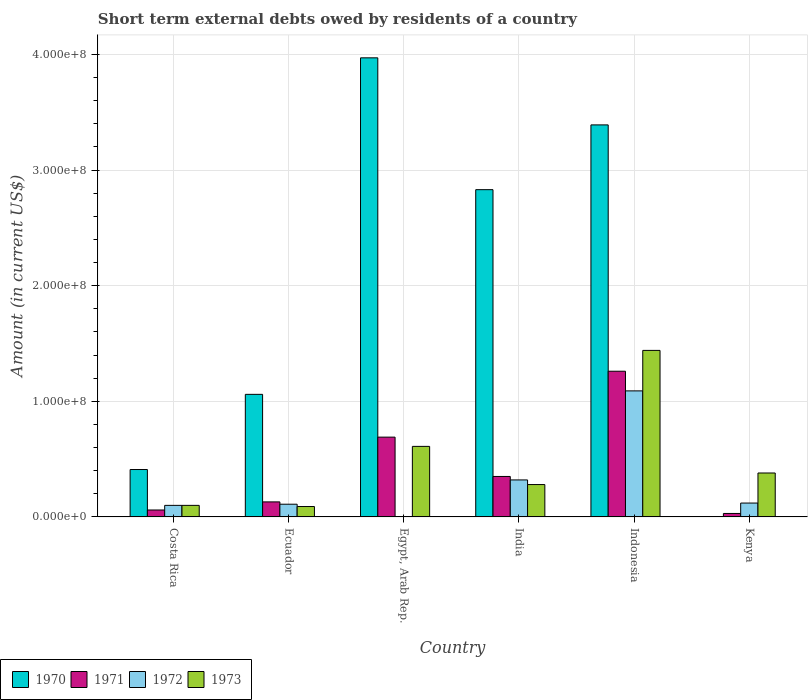How many different coloured bars are there?
Make the answer very short. 4. How many groups of bars are there?
Offer a terse response. 6. Are the number of bars per tick equal to the number of legend labels?
Offer a very short reply. No. Are the number of bars on each tick of the X-axis equal?
Your answer should be very brief. No. How many bars are there on the 6th tick from the left?
Keep it short and to the point. 3. In how many cases, is the number of bars for a given country not equal to the number of legend labels?
Make the answer very short. 2. What is the amount of short-term external debts owed by residents in 1970 in Indonesia?
Provide a short and direct response. 3.39e+08. Across all countries, what is the maximum amount of short-term external debts owed by residents in 1973?
Keep it short and to the point. 1.44e+08. Across all countries, what is the minimum amount of short-term external debts owed by residents in 1973?
Give a very brief answer. 9.00e+06. In which country was the amount of short-term external debts owed by residents in 1970 maximum?
Give a very brief answer. Egypt, Arab Rep. What is the total amount of short-term external debts owed by residents in 1970 in the graph?
Give a very brief answer. 1.17e+09. What is the difference between the amount of short-term external debts owed by residents in 1971 in Ecuador and that in Kenya?
Make the answer very short. 1.00e+07. What is the difference between the amount of short-term external debts owed by residents in 1970 in Kenya and the amount of short-term external debts owed by residents in 1972 in Indonesia?
Offer a very short reply. -1.09e+08. What is the average amount of short-term external debts owed by residents in 1972 per country?
Provide a short and direct response. 2.90e+07. What is the difference between the amount of short-term external debts owed by residents of/in 1973 and amount of short-term external debts owed by residents of/in 1972 in Indonesia?
Keep it short and to the point. 3.50e+07. What is the ratio of the amount of short-term external debts owed by residents in 1970 in Ecuador to that in Indonesia?
Give a very brief answer. 0.31. What is the difference between the highest and the second highest amount of short-term external debts owed by residents in 1971?
Provide a succinct answer. 5.70e+07. What is the difference between the highest and the lowest amount of short-term external debts owed by residents in 1971?
Provide a short and direct response. 1.23e+08. In how many countries, is the amount of short-term external debts owed by residents in 1972 greater than the average amount of short-term external debts owed by residents in 1972 taken over all countries?
Provide a short and direct response. 2. Is the sum of the amount of short-term external debts owed by residents in 1971 in Ecuador and India greater than the maximum amount of short-term external debts owed by residents in 1972 across all countries?
Offer a terse response. No. Are all the bars in the graph horizontal?
Make the answer very short. No. How many countries are there in the graph?
Provide a short and direct response. 6. Does the graph contain any zero values?
Provide a short and direct response. Yes. Where does the legend appear in the graph?
Offer a very short reply. Bottom left. How many legend labels are there?
Offer a terse response. 4. What is the title of the graph?
Provide a short and direct response. Short term external debts owed by residents of a country. What is the label or title of the X-axis?
Make the answer very short. Country. What is the label or title of the Y-axis?
Give a very brief answer. Amount (in current US$). What is the Amount (in current US$) in 1970 in Costa Rica?
Provide a succinct answer. 4.10e+07. What is the Amount (in current US$) in 1972 in Costa Rica?
Provide a succinct answer. 1.00e+07. What is the Amount (in current US$) in 1973 in Costa Rica?
Your answer should be very brief. 1.00e+07. What is the Amount (in current US$) of 1970 in Ecuador?
Keep it short and to the point. 1.06e+08. What is the Amount (in current US$) in 1971 in Ecuador?
Make the answer very short. 1.30e+07. What is the Amount (in current US$) in 1972 in Ecuador?
Your answer should be compact. 1.10e+07. What is the Amount (in current US$) of 1973 in Ecuador?
Your answer should be very brief. 9.00e+06. What is the Amount (in current US$) in 1970 in Egypt, Arab Rep.?
Ensure brevity in your answer.  3.97e+08. What is the Amount (in current US$) in 1971 in Egypt, Arab Rep.?
Your response must be concise. 6.90e+07. What is the Amount (in current US$) of 1972 in Egypt, Arab Rep.?
Offer a very short reply. 0. What is the Amount (in current US$) of 1973 in Egypt, Arab Rep.?
Your response must be concise. 6.10e+07. What is the Amount (in current US$) in 1970 in India?
Provide a succinct answer. 2.83e+08. What is the Amount (in current US$) in 1971 in India?
Provide a succinct answer. 3.50e+07. What is the Amount (in current US$) in 1972 in India?
Your answer should be compact. 3.20e+07. What is the Amount (in current US$) in 1973 in India?
Your response must be concise. 2.80e+07. What is the Amount (in current US$) of 1970 in Indonesia?
Ensure brevity in your answer.  3.39e+08. What is the Amount (in current US$) of 1971 in Indonesia?
Make the answer very short. 1.26e+08. What is the Amount (in current US$) of 1972 in Indonesia?
Offer a very short reply. 1.09e+08. What is the Amount (in current US$) of 1973 in Indonesia?
Provide a short and direct response. 1.44e+08. What is the Amount (in current US$) in 1971 in Kenya?
Ensure brevity in your answer.  3.00e+06. What is the Amount (in current US$) in 1973 in Kenya?
Provide a succinct answer. 3.80e+07. Across all countries, what is the maximum Amount (in current US$) in 1970?
Offer a terse response. 3.97e+08. Across all countries, what is the maximum Amount (in current US$) of 1971?
Keep it short and to the point. 1.26e+08. Across all countries, what is the maximum Amount (in current US$) in 1972?
Your answer should be very brief. 1.09e+08. Across all countries, what is the maximum Amount (in current US$) in 1973?
Offer a very short reply. 1.44e+08. Across all countries, what is the minimum Amount (in current US$) of 1972?
Provide a succinct answer. 0. Across all countries, what is the minimum Amount (in current US$) in 1973?
Provide a short and direct response. 9.00e+06. What is the total Amount (in current US$) of 1970 in the graph?
Your response must be concise. 1.17e+09. What is the total Amount (in current US$) in 1971 in the graph?
Provide a short and direct response. 2.52e+08. What is the total Amount (in current US$) in 1972 in the graph?
Provide a short and direct response. 1.74e+08. What is the total Amount (in current US$) in 1973 in the graph?
Your answer should be very brief. 2.90e+08. What is the difference between the Amount (in current US$) in 1970 in Costa Rica and that in Ecuador?
Offer a very short reply. -6.50e+07. What is the difference between the Amount (in current US$) of 1971 in Costa Rica and that in Ecuador?
Keep it short and to the point. -7.00e+06. What is the difference between the Amount (in current US$) in 1973 in Costa Rica and that in Ecuador?
Provide a short and direct response. 1.00e+06. What is the difference between the Amount (in current US$) of 1970 in Costa Rica and that in Egypt, Arab Rep.?
Keep it short and to the point. -3.56e+08. What is the difference between the Amount (in current US$) in 1971 in Costa Rica and that in Egypt, Arab Rep.?
Ensure brevity in your answer.  -6.30e+07. What is the difference between the Amount (in current US$) in 1973 in Costa Rica and that in Egypt, Arab Rep.?
Your response must be concise. -5.10e+07. What is the difference between the Amount (in current US$) of 1970 in Costa Rica and that in India?
Provide a succinct answer. -2.42e+08. What is the difference between the Amount (in current US$) in 1971 in Costa Rica and that in India?
Offer a very short reply. -2.90e+07. What is the difference between the Amount (in current US$) of 1972 in Costa Rica and that in India?
Offer a very short reply. -2.20e+07. What is the difference between the Amount (in current US$) of 1973 in Costa Rica and that in India?
Ensure brevity in your answer.  -1.80e+07. What is the difference between the Amount (in current US$) in 1970 in Costa Rica and that in Indonesia?
Provide a short and direct response. -2.98e+08. What is the difference between the Amount (in current US$) of 1971 in Costa Rica and that in Indonesia?
Your answer should be very brief. -1.20e+08. What is the difference between the Amount (in current US$) in 1972 in Costa Rica and that in Indonesia?
Make the answer very short. -9.90e+07. What is the difference between the Amount (in current US$) in 1973 in Costa Rica and that in Indonesia?
Provide a succinct answer. -1.34e+08. What is the difference between the Amount (in current US$) of 1971 in Costa Rica and that in Kenya?
Give a very brief answer. 3.00e+06. What is the difference between the Amount (in current US$) of 1972 in Costa Rica and that in Kenya?
Offer a terse response. -2.00e+06. What is the difference between the Amount (in current US$) in 1973 in Costa Rica and that in Kenya?
Offer a terse response. -2.80e+07. What is the difference between the Amount (in current US$) of 1970 in Ecuador and that in Egypt, Arab Rep.?
Make the answer very short. -2.91e+08. What is the difference between the Amount (in current US$) of 1971 in Ecuador and that in Egypt, Arab Rep.?
Offer a terse response. -5.60e+07. What is the difference between the Amount (in current US$) of 1973 in Ecuador and that in Egypt, Arab Rep.?
Give a very brief answer. -5.20e+07. What is the difference between the Amount (in current US$) of 1970 in Ecuador and that in India?
Give a very brief answer. -1.77e+08. What is the difference between the Amount (in current US$) of 1971 in Ecuador and that in India?
Offer a very short reply. -2.20e+07. What is the difference between the Amount (in current US$) of 1972 in Ecuador and that in India?
Offer a terse response. -2.10e+07. What is the difference between the Amount (in current US$) of 1973 in Ecuador and that in India?
Your answer should be very brief. -1.90e+07. What is the difference between the Amount (in current US$) in 1970 in Ecuador and that in Indonesia?
Your answer should be compact. -2.33e+08. What is the difference between the Amount (in current US$) of 1971 in Ecuador and that in Indonesia?
Provide a short and direct response. -1.13e+08. What is the difference between the Amount (in current US$) of 1972 in Ecuador and that in Indonesia?
Your answer should be compact. -9.80e+07. What is the difference between the Amount (in current US$) of 1973 in Ecuador and that in Indonesia?
Ensure brevity in your answer.  -1.35e+08. What is the difference between the Amount (in current US$) in 1971 in Ecuador and that in Kenya?
Provide a short and direct response. 1.00e+07. What is the difference between the Amount (in current US$) in 1973 in Ecuador and that in Kenya?
Make the answer very short. -2.90e+07. What is the difference between the Amount (in current US$) in 1970 in Egypt, Arab Rep. and that in India?
Ensure brevity in your answer.  1.14e+08. What is the difference between the Amount (in current US$) in 1971 in Egypt, Arab Rep. and that in India?
Your response must be concise. 3.40e+07. What is the difference between the Amount (in current US$) in 1973 in Egypt, Arab Rep. and that in India?
Ensure brevity in your answer.  3.30e+07. What is the difference between the Amount (in current US$) of 1970 in Egypt, Arab Rep. and that in Indonesia?
Offer a terse response. 5.80e+07. What is the difference between the Amount (in current US$) of 1971 in Egypt, Arab Rep. and that in Indonesia?
Give a very brief answer. -5.70e+07. What is the difference between the Amount (in current US$) in 1973 in Egypt, Arab Rep. and that in Indonesia?
Ensure brevity in your answer.  -8.30e+07. What is the difference between the Amount (in current US$) in 1971 in Egypt, Arab Rep. and that in Kenya?
Provide a short and direct response. 6.60e+07. What is the difference between the Amount (in current US$) in 1973 in Egypt, Arab Rep. and that in Kenya?
Your response must be concise. 2.30e+07. What is the difference between the Amount (in current US$) of 1970 in India and that in Indonesia?
Provide a succinct answer. -5.60e+07. What is the difference between the Amount (in current US$) in 1971 in India and that in Indonesia?
Make the answer very short. -9.10e+07. What is the difference between the Amount (in current US$) of 1972 in India and that in Indonesia?
Offer a terse response. -7.70e+07. What is the difference between the Amount (in current US$) of 1973 in India and that in Indonesia?
Keep it short and to the point. -1.16e+08. What is the difference between the Amount (in current US$) in 1971 in India and that in Kenya?
Keep it short and to the point. 3.20e+07. What is the difference between the Amount (in current US$) in 1972 in India and that in Kenya?
Offer a terse response. 2.00e+07. What is the difference between the Amount (in current US$) in 1973 in India and that in Kenya?
Provide a succinct answer. -1.00e+07. What is the difference between the Amount (in current US$) of 1971 in Indonesia and that in Kenya?
Your response must be concise. 1.23e+08. What is the difference between the Amount (in current US$) of 1972 in Indonesia and that in Kenya?
Provide a succinct answer. 9.70e+07. What is the difference between the Amount (in current US$) of 1973 in Indonesia and that in Kenya?
Offer a very short reply. 1.06e+08. What is the difference between the Amount (in current US$) of 1970 in Costa Rica and the Amount (in current US$) of 1971 in Ecuador?
Give a very brief answer. 2.80e+07. What is the difference between the Amount (in current US$) of 1970 in Costa Rica and the Amount (in current US$) of 1972 in Ecuador?
Offer a very short reply. 3.00e+07. What is the difference between the Amount (in current US$) of 1970 in Costa Rica and the Amount (in current US$) of 1973 in Ecuador?
Your answer should be compact. 3.20e+07. What is the difference between the Amount (in current US$) in 1971 in Costa Rica and the Amount (in current US$) in 1972 in Ecuador?
Provide a succinct answer. -5.00e+06. What is the difference between the Amount (in current US$) in 1970 in Costa Rica and the Amount (in current US$) in 1971 in Egypt, Arab Rep.?
Your answer should be very brief. -2.80e+07. What is the difference between the Amount (in current US$) of 1970 in Costa Rica and the Amount (in current US$) of 1973 in Egypt, Arab Rep.?
Provide a succinct answer. -2.00e+07. What is the difference between the Amount (in current US$) of 1971 in Costa Rica and the Amount (in current US$) of 1973 in Egypt, Arab Rep.?
Provide a short and direct response. -5.50e+07. What is the difference between the Amount (in current US$) in 1972 in Costa Rica and the Amount (in current US$) in 1973 in Egypt, Arab Rep.?
Provide a short and direct response. -5.10e+07. What is the difference between the Amount (in current US$) in 1970 in Costa Rica and the Amount (in current US$) in 1971 in India?
Keep it short and to the point. 6.00e+06. What is the difference between the Amount (in current US$) of 1970 in Costa Rica and the Amount (in current US$) of 1972 in India?
Give a very brief answer. 9.00e+06. What is the difference between the Amount (in current US$) in 1970 in Costa Rica and the Amount (in current US$) in 1973 in India?
Provide a succinct answer. 1.30e+07. What is the difference between the Amount (in current US$) of 1971 in Costa Rica and the Amount (in current US$) of 1972 in India?
Your answer should be very brief. -2.60e+07. What is the difference between the Amount (in current US$) in 1971 in Costa Rica and the Amount (in current US$) in 1973 in India?
Make the answer very short. -2.20e+07. What is the difference between the Amount (in current US$) of 1972 in Costa Rica and the Amount (in current US$) of 1973 in India?
Offer a terse response. -1.80e+07. What is the difference between the Amount (in current US$) of 1970 in Costa Rica and the Amount (in current US$) of 1971 in Indonesia?
Keep it short and to the point. -8.50e+07. What is the difference between the Amount (in current US$) in 1970 in Costa Rica and the Amount (in current US$) in 1972 in Indonesia?
Keep it short and to the point. -6.80e+07. What is the difference between the Amount (in current US$) of 1970 in Costa Rica and the Amount (in current US$) of 1973 in Indonesia?
Your answer should be compact. -1.03e+08. What is the difference between the Amount (in current US$) of 1971 in Costa Rica and the Amount (in current US$) of 1972 in Indonesia?
Your answer should be compact. -1.03e+08. What is the difference between the Amount (in current US$) in 1971 in Costa Rica and the Amount (in current US$) in 1973 in Indonesia?
Give a very brief answer. -1.38e+08. What is the difference between the Amount (in current US$) of 1972 in Costa Rica and the Amount (in current US$) of 1973 in Indonesia?
Ensure brevity in your answer.  -1.34e+08. What is the difference between the Amount (in current US$) of 1970 in Costa Rica and the Amount (in current US$) of 1971 in Kenya?
Ensure brevity in your answer.  3.80e+07. What is the difference between the Amount (in current US$) of 1970 in Costa Rica and the Amount (in current US$) of 1972 in Kenya?
Make the answer very short. 2.90e+07. What is the difference between the Amount (in current US$) of 1970 in Costa Rica and the Amount (in current US$) of 1973 in Kenya?
Provide a short and direct response. 3.00e+06. What is the difference between the Amount (in current US$) of 1971 in Costa Rica and the Amount (in current US$) of 1972 in Kenya?
Give a very brief answer. -6.00e+06. What is the difference between the Amount (in current US$) in 1971 in Costa Rica and the Amount (in current US$) in 1973 in Kenya?
Offer a terse response. -3.20e+07. What is the difference between the Amount (in current US$) of 1972 in Costa Rica and the Amount (in current US$) of 1973 in Kenya?
Offer a very short reply. -2.80e+07. What is the difference between the Amount (in current US$) of 1970 in Ecuador and the Amount (in current US$) of 1971 in Egypt, Arab Rep.?
Ensure brevity in your answer.  3.70e+07. What is the difference between the Amount (in current US$) of 1970 in Ecuador and the Amount (in current US$) of 1973 in Egypt, Arab Rep.?
Give a very brief answer. 4.50e+07. What is the difference between the Amount (in current US$) in 1971 in Ecuador and the Amount (in current US$) in 1973 in Egypt, Arab Rep.?
Your response must be concise. -4.80e+07. What is the difference between the Amount (in current US$) in 1972 in Ecuador and the Amount (in current US$) in 1973 in Egypt, Arab Rep.?
Ensure brevity in your answer.  -5.00e+07. What is the difference between the Amount (in current US$) in 1970 in Ecuador and the Amount (in current US$) in 1971 in India?
Keep it short and to the point. 7.10e+07. What is the difference between the Amount (in current US$) in 1970 in Ecuador and the Amount (in current US$) in 1972 in India?
Your response must be concise. 7.40e+07. What is the difference between the Amount (in current US$) of 1970 in Ecuador and the Amount (in current US$) of 1973 in India?
Offer a terse response. 7.80e+07. What is the difference between the Amount (in current US$) of 1971 in Ecuador and the Amount (in current US$) of 1972 in India?
Offer a very short reply. -1.90e+07. What is the difference between the Amount (in current US$) of 1971 in Ecuador and the Amount (in current US$) of 1973 in India?
Ensure brevity in your answer.  -1.50e+07. What is the difference between the Amount (in current US$) in 1972 in Ecuador and the Amount (in current US$) in 1973 in India?
Give a very brief answer. -1.70e+07. What is the difference between the Amount (in current US$) of 1970 in Ecuador and the Amount (in current US$) of 1971 in Indonesia?
Ensure brevity in your answer.  -2.00e+07. What is the difference between the Amount (in current US$) of 1970 in Ecuador and the Amount (in current US$) of 1973 in Indonesia?
Provide a succinct answer. -3.80e+07. What is the difference between the Amount (in current US$) of 1971 in Ecuador and the Amount (in current US$) of 1972 in Indonesia?
Your response must be concise. -9.60e+07. What is the difference between the Amount (in current US$) of 1971 in Ecuador and the Amount (in current US$) of 1973 in Indonesia?
Offer a very short reply. -1.31e+08. What is the difference between the Amount (in current US$) of 1972 in Ecuador and the Amount (in current US$) of 1973 in Indonesia?
Give a very brief answer. -1.33e+08. What is the difference between the Amount (in current US$) of 1970 in Ecuador and the Amount (in current US$) of 1971 in Kenya?
Make the answer very short. 1.03e+08. What is the difference between the Amount (in current US$) of 1970 in Ecuador and the Amount (in current US$) of 1972 in Kenya?
Your answer should be compact. 9.40e+07. What is the difference between the Amount (in current US$) in 1970 in Ecuador and the Amount (in current US$) in 1973 in Kenya?
Give a very brief answer. 6.80e+07. What is the difference between the Amount (in current US$) of 1971 in Ecuador and the Amount (in current US$) of 1972 in Kenya?
Provide a succinct answer. 1.00e+06. What is the difference between the Amount (in current US$) of 1971 in Ecuador and the Amount (in current US$) of 1973 in Kenya?
Ensure brevity in your answer.  -2.50e+07. What is the difference between the Amount (in current US$) in 1972 in Ecuador and the Amount (in current US$) in 1973 in Kenya?
Your response must be concise. -2.70e+07. What is the difference between the Amount (in current US$) in 1970 in Egypt, Arab Rep. and the Amount (in current US$) in 1971 in India?
Offer a very short reply. 3.62e+08. What is the difference between the Amount (in current US$) in 1970 in Egypt, Arab Rep. and the Amount (in current US$) in 1972 in India?
Ensure brevity in your answer.  3.65e+08. What is the difference between the Amount (in current US$) in 1970 in Egypt, Arab Rep. and the Amount (in current US$) in 1973 in India?
Give a very brief answer. 3.69e+08. What is the difference between the Amount (in current US$) in 1971 in Egypt, Arab Rep. and the Amount (in current US$) in 1972 in India?
Make the answer very short. 3.70e+07. What is the difference between the Amount (in current US$) in 1971 in Egypt, Arab Rep. and the Amount (in current US$) in 1973 in India?
Offer a very short reply. 4.10e+07. What is the difference between the Amount (in current US$) of 1970 in Egypt, Arab Rep. and the Amount (in current US$) of 1971 in Indonesia?
Offer a terse response. 2.71e+08. What is the difference between the Amount (in current US$) in 1970 in Egypt, Arab Rep. and the Amount (in current US$) in 1972 in Indonesia?
Provide a succinct answer. 2.88e+08. What is the difference between the Amount (in current US$) in 1970 in Egypt, Arab Rep. and the Amount (in current US$) in 1973 in Indonesia?
Your response must be concise. 2.53e+08. What is the difference between the Amount (in current US$) in 1971 in Egypt, Arab Rep. and the Amount (in current US$) in 1972 in Indonesia?
Your answer should be compact. -4.00e+07. What is the difference between the Amount (in current US$) of 1971 in Egypt, Arab Rep. and the Amount (in current US$) of 1973 in Indonesia?
Ensure brevity in your answer.  -7.50e+07. What is the difference between the Amount (in current US$) in 1970 in Egypt, Arab Rep. and the Amount (in current US$) in 1971 in Kenya?
Provide a succinct answer. 3.94e+08. What is the difference between the Amount (in current US$) of 1970 in Egypt, Arab Rep. and the Amount (in current US$) of 1972 in Kenya?
Provide a short and direct response. 3.85e+08. What is the difference between the Amount (in current US$) of 1970 in Egypt, Arab Rep. and the Amount (in current US$) of 1973 in Kenya?
Keep it short and to the point. 3.59e+08. What is the difference between the Amount (in current US$) of 1971 in Egypt, Arab Rep. and the Amount (in current US$) of 1972 in Kenya?
Keep it short and to the point. 5.70e+07. What is the difference between the Amount (in current US$) of 1971 in Egypt, Arab Rep. and the Amount (in current US$) of 1973 in Kenya?
Offer a terse response. 3.10e+07. What is the difference between the Amount (in current US$) in 1970 in India and the Amount (in current US$) in 1971 in Indonesia?
Your answer should be very brief. 1.57e+08. What is the difference between the Amount (in current US$) of 1970 in India and the Amount (in current US$) of 1972 in Indonesia?
Your answer should be compact. 1.74e+08. What is the difference between the Amount (in current US$) of 1970 in India and the Amount (in current US$) of 1973 in Indonesia?
Your answer should be very brief. 1.39e+08. What is the difference between the Amount (in current US$) in 1971 in India and the Amount (in current US$) in 1972 in Indonesia?
Your response must be concise. -7.40e+07. What is the difference between the Amount (in current US$) in 1971 in India and the Amount (in current US$) in 1973 in Indonesia?
Your answer should be very brief. -1.09e+08. What is the difference between the Amount (in current US$) of 1972 in India and the Amount (in current US$) of 1973 in Indonesia?
Keep it short and to the point. -1.12e+08. What is the difference between the Amount (in current US$) in 1970 in India and the Amount (in current US$) in 1971 in Kenya?
Give a very brief answer. 2.80e+08. What is the difference between the Amount (in current US$) in 1970 in India and the Amount (in current US$) in 1972 in Kenya?
Give a very brief answer. 2.71e+08. What is the difference between the Amount (in current US$) of 1970 in India and the Amount (in current US$) of 1973 in Kenya?
Give a very brief answer. 2.45e+08. What is the difference between the Amount (in current US$) of 1971 in India and the Amount (in current US$) of 1972 in Kenya?
Your answer should be compact. 2.30e+07. What is the difference between the Amount (in current US$) of 1971 in India and the Amount (in current US$) of 1973 in Kenya?
Your answer should be compact. -3.00e+06. What is the difference between the Amount (in current US$) in 1972 in India and the Amount (in current US$) in 1973 in Kenya?
Give a very brief answer. -6.00e+06. What is the difference between the Amount (in current US$) of 1970 in Indonesia and the Amount (in current US$) of 1971 in Kenya?
Provide a short and direct response. 3.36e+08. What is the difference between the Amount (in current US$) of 1970 in Indonesia and the Amount (in current US$) of 1972 in Kenya?
Your answer should be compact. 3.27e+08. What is the difference between the Amount (in current US$) of 1970 in Indonesia and the Amount (in current US$) of 1973 in Kenya?
Ensure brevity in your answer.  3.01e+08. What is the difference between the Amount (in current US$) in 1971 in Indonesia and the Amount (in current US$) in 1972 in Kenya?
Keep it short and to the point. 1.14e+08. What is the difference between the Amount (in current US$) of 1971 in Indonesia and the Amount (in current US$) of 1973 in Kenya?
Make the answer very short. 8.80e+07. What is the difference between the Amount (in current US$) in 1972 in Indonesia and the Amount (in current US$) in 1973 in Kenya?
Your response must be concise. 7.10e+07. What is the average Amount (in current US$) of 1970 per country?
Offer a terse response. 1.94e+08. What is the average Amount (in current US$) of 1971 per country?
Provide a short and direct response. 4.20e+07. What is the average Amount (in current US$) in 1972 per country?
Your answer should be very brief. 2.90e+07. What is the average Amount (in current US$) in 1973 per country?
Keep it short and to the point. 4.83e+07. What is the difference between the Amount (in current US$) in 1970 and Amount (in current US$) in 1971 in Costa Rica?
Your answer should be compact. 3.50e+07. What is the difference between the Amount (in current US$) in 1970 and Amount (in current US$) in 1972 in Costa Rica?
Make the answer very short. 3.10e+07. What is the difference between the Amount (in current US$) of 1970 and Amount (in current US$) of 1973 in Costa Rica?
Make the answer very short. 3.10e+07. What is the difference between the Amount (in current US$) in 1970 and Amount (in current US$) in 1971 in Ecuador?
Ensure brevity in your answer.  9.30e+07. What is the difference between the Amount (in current US$) in 1970 and Amount (in current US$) in 1972 in Ecuador?
Provide a short and direct response. 9.50e+07. What is the difference between the Amount (in current US$) of 1970 and Amount (in current US$) of 1973 in Ecuador?
Make the answer very short. 9.70e+07. What is the difference between the Amount (in current US$) in 1971 and Amount (in current US$) in 1973 in Ecuador?
Provide a short and direct response. 4.00e+06. What is the difference between the Amount (in current US$) of 1970 and Amount (in current US$) of 1971 in Egypt, Arab Rep.?
Provide a short and direct response. 3.28e+08. What is the difference between the Amount (in current US$) in 1970 and Amount (in current US$) in 1973 in Egypt, Arab Rep.?
Ensure brevity in your answer.  3.36e+08. What is the difference between the Amount (in current US$) of 1971 and Amount (in current US$) of 1973 in Egypt, Arab Rep.?
Your response must be concise. 8.00e+06. What is the difference between the Amount (in current US$) of 1970 and Amount (in current US$) of 1971 in India?
Your response must be concise. 2.48e+08. What is the difference between the Amount (in current US$) in 1970 and Amount (in current US$) in 1972 in India?
Keep it short and to the point. 2.51e+08. What is the difference between the Amount (in current US$) in 1970 and Amount (in current US$) in 1973 in India?
Your response must be concise. 2.55e+08. What is the difference between the Amount (in current US$) in 1972 and Amount (in current US$) in 1973 in India?
Your response must be concise. 4.00e+06. What is the difference between the Amount (in current US$) of 1970 and Amount (in current US$) of 1971 in Indonesia?
Ensure brevity in your answer.  2.13e+08. What is the difference between the Amount (in current US$) in 1970 and Amount (in current US$) in 1972 in Indonesia?
Provide a short and direct response. 2.30e+08. What is the difference between the Amount (in current US$) in 1970 and Amount (in current US$) in 1973 in Indonesia?
Provide a short and direct response. 1.95e+08. What is the difference between the Amount (in current US$) in 1971 and Amount (in current US$) in 1972 in Indonesia?
Your answer should be compact. 1.70e+07. What is the difference between the Amount (in current US$) of 1971 and Amount (in current US$) of 1973 in Indonesia?
Your answer should be very brief. -1.80e+07. What is the difference between the Amount (in current US$) in 1972 and Amount (in current US$) in 1973 in Indonesia?
Provide a short and direct response. -3.50e+07. What is the difference between the Amount (in current US$) in 1971 and Amount (in current US$) in 1972 in Kenya?
Make the answer very short. -9.00e+06. What is the difference between the Amount (in current US$) of 1971 and Amount (in current US$) of 1973 in Kenya?
Ensure brevity in your answer.  -3.50e+07. What is the difference between the Amount (in current US$) of 1972 and Amount (in current US$) of 1973 in Kenya?
Provide a short and direct response. -2.60e+07. What is the ratio of the Amount (in current US$) in 1970 in Costa Rica to that in Ecuador?
Give a very brief answer. 0.39. What is the ratio of the Amount (in current US$) of 1971 in Costa Rica to that in Ecuador?
Provide a short and direct response. 0.46. What is the ratio of the Amount (in current US$) of 1972 in Costa Rica to that in Ecuador?
Your response must be concise. 0.91. What is the ratio of the Amount (in current US$) of 1970 in Costa Rica to that in Egypt, Arab Rep.?
Keep it short and to the point. 0.1. What is the ratio of the Amount (in current US$) of 1971 in Costa Rica to that in Egypt, Arab Rep.?
Your response must be concise. 0.09. What is the ratio of the Amount (in current US$) in 1973 in Costa Rica to that in Egypt, Arab Rep.?
Keep it short and to the point. 0.16. What is the ratio of the Amount (in current US$) in 1970 in Costa Rica to that in India?
Keep it short and to the point. 0.14. What is the ratio of the Amount (in current US$) in 1971 in Costa Rica to that in India?
Your answer should be very brief. 0.17. What is the ratio of the Amount (in current US$) of 1972 in Costa Rica to that in India?
Your response must be concise. 0.31. What is the ratio of the Amount (in current US$) in 1973 in Costa Rica to that in India?
Provide a succinct answer. 0.36. What is the ratio of the Amount (in current US$) in 1970 in Costa Rica to that in Indonesia?
Ensure brevity in your answer.  0.12. What is the ratio of the Amount (in current US$) of 1971 in Costa Rica to that in Indonesia?
Your answer should be compact. 0.05. What is the ratio of the Amount (in current US$) in 1972 in Costa Rica to that in Indonesia?
Your answer should be very brief. 0.09. What is the ratio of the Amount (in current US$) in 1973 in Costa Rica to that in Indonesia?
Your response must be concise. 0.07. What is the ratio of the Amount (in current US$) in 1973 in Costa Rica to that in Kenya?
Offer a terse response. 0.26. What is the ratio of the Amount (in current US$) of 1970 in Ecuador to that in Egypt, Arab Rep.?
Offer a very short reply. 0.27. What is the ratio of the Amount (in current US$) of 1971 in Ecuador to that in Egypt, Arab Rep.?
Offer a very short reply. 0.19. What is the ratio of the Amount (in current US$) of 1973 in Ecuador to that in Egypt, Arab Rep.?
Provide a succinct answer. 0.15. What is the ratio of the Amount (in current US$) in 1970 in Ecuador to that in India?
Offer a terse response. 0.37. What is the ratio of the Amount (in current US$) of 1971 in Ecuador to that in India?
Keep it short and to the point. 0.37. What is the ratio of the Amount (in current US$) in 1972 in Ecuador to that in India?
Offer a terse response. 0.34. What is the ratio of the Amount (in current US$) in 1973 in Ecuador to that in India?
Your response must be concise. 0.32. What is the ratio of the Amount (in current US$) in 1970 in Ecuador to that in Indonesia?
Give a very brief answer. 0.31. What is the ratio of the Amount (in current US$) of 1971 in Ecuador to that in Indonesia?
Provide a succinct answer. 0.1. What is the ratio of the Amount (in current US$) of 1972 in Ecuador to that in Indonesia?
Offer a terse response. 0.1. What is the ratio of the Amount (in current US$) in 1973 in Ecuador to that in Indonesia?
Provide a succinct answer. 0.06. What is the ratio of the Amount (in current US$) in 1971 in Ecuador to that in Kenya?
Give a very brief answer. 4.33. What is the ratio of the Amount (in current US$) in 1972 in Ecuador to that in Kenya?
Your answer should be compact. 0.92. What is the ratio of the Amount (in current US$) of 1973 in Ecuador to that in Kenya?
Keep it short and to the point. 0.24. What is the ratio of the Amount (in current US$) in 1970 in Egypt, Arab Rep. to that in India?
Offer a terse response. 1.4. What is the ratio of the Amount (in current US$) in 1971 in Egypt, Arab Rep. to that in India?
Ensure brevity in your answer.  1.97. What is the ratio of the Amount (in current US$) in 1973 in Egypt, Arab Rep. to that in India?
Your answer should be compact. 2.18. What is the ratio of the Amount (in current US$) in 1970 in Egypt, Arab Rep. to that in Indonesia?
Your answer should be compact. 1.17. What is the ratio of the Amount (in current US$) of 1971 in Egypt, Arab Rep. to that in Indonesia?
Provide a short and direct response. 0.55. What is the ratio of the Amount (in current US$) in 1973 in Egypt, Arab Rep. to that in Indonesia?
Your answer should be very brief. 0.42. What is the ratio of the Amount (in current US$) in 1973 in Egypt, Arab Rep. to that in Kenya?
Provide a short and direct response. 1.61. What is the ratio of the Amount (in current US$) in 1970 in India to that in Indonesia?
Provide a short and direct response. 0.83. What is the ratio of the Amount (in current US$) of 1971 in India to that in Indonesia?
Your answer should be very brief. 0.28. What is the ratio of the Amount (in current US$) of 1972 in India to that in Indonesia?
Your response must be concise. 0.29. What is the ratio of the Amount (in current US$) in 1973 in India to that in Indonesia?
Your answer should be compact. 0.19. What is the ratio of the Amount (in current US$) of 1971 in India to that in Kenya?
Provide a succinct answer. 11.67. What is the ratio of the Amount (in current US$) of 1972 in India to that in Kenya?
Ensure brevity in your answer.  2.67. What is the ratio of the Amount (in current US$) in 1973 in India to that in Kenya?
Give a very brief answer. 0.74. What is the ratio of the Amount (in current US$) of 1971 in Indonesia to that in Kenya?
Give a very brief answer. 42. What is the ratio of the Amount (in current US$) of 1972 in Indonesia to that in Kenya?
Make the answer very short. 9.08. What is the ratio of the Amount (in current US$) of 1973 in Indonesia to that in Kenya?
Offer a terse response. 3.79. What is the difference between the highest and the second highest Amount (in current US$) of 1970?
Ensure brevity in your answer.  5.80e+07. What is the difference between the highest and the second highest Amount (in current US$) in 1971?
Keep it short and to the point. 5.70e+07. What is the difference between the highest and the second highest Amount (in current US$) of 1972?
Provide a succinct answer. 7.70e+07. What is the difference between the highest and the second highest Amount (in current US$) of 1973?
Make the answer very short. 8.30e+07. What is the difference between the highest and the lowest Amount (in current US$) in 1970?
Provide a succinct answer. 3.97e+08. What is the difference between the highest and the lowest Amount (in current US$) of 1971?
Provide a short and direct response. 1.23e+08. What is the difference between the highest and the lowest Amount (in current US$) in 1972?
Your answer should be compact. 1.09e+08. What is the difference between the highest and the lowest Amount (in current US$) in 1973?
Provide a succinct answer. 1.35e+08. 